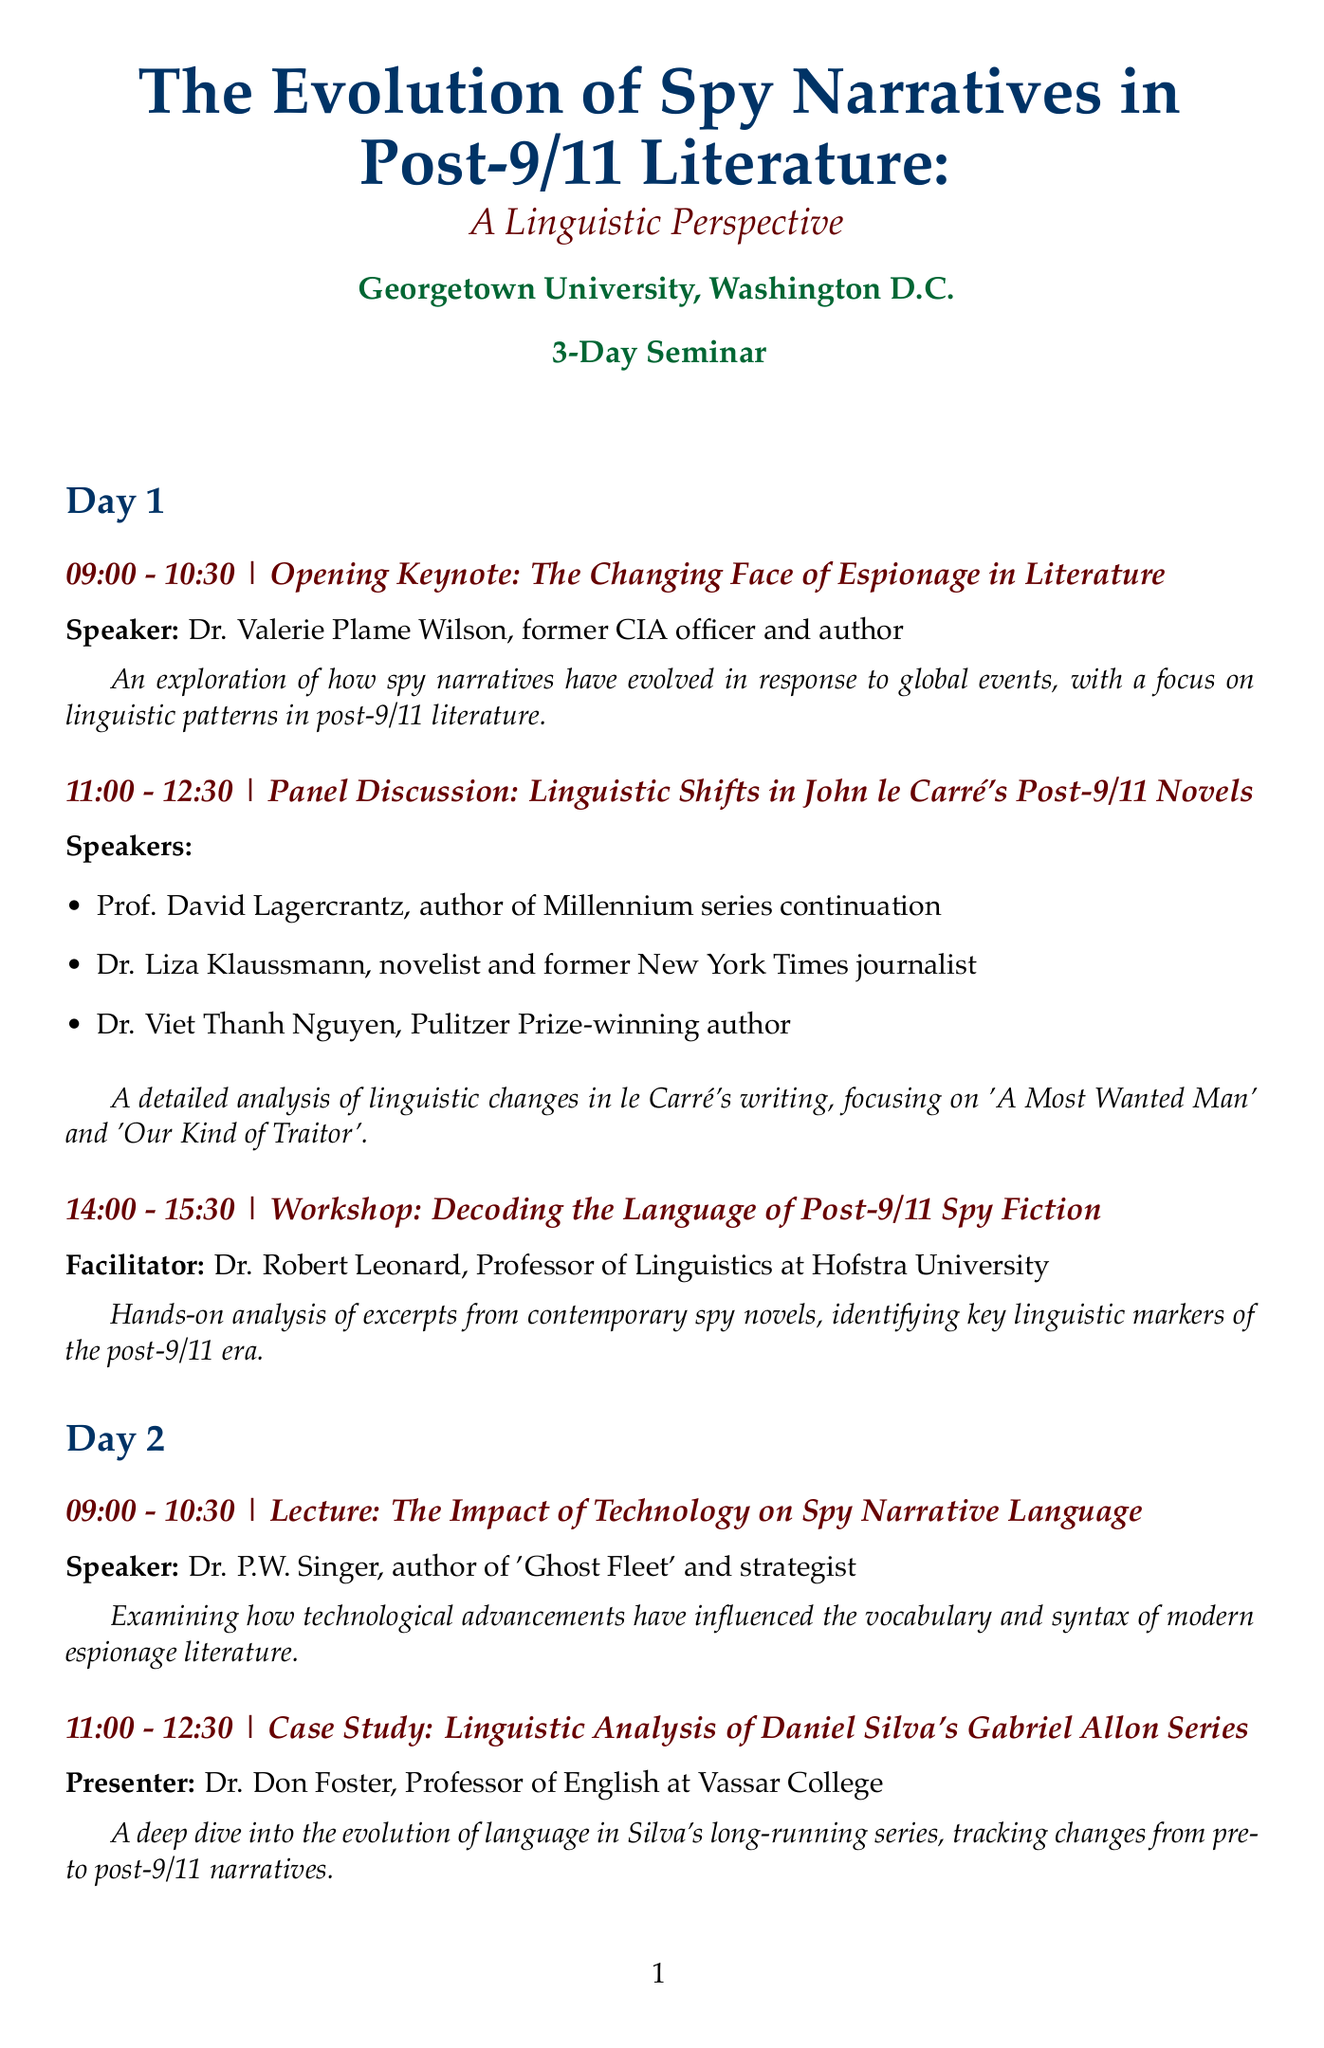What is the title of the seminar? The title is clearly stated at the start of the document.
Answer: The Evolution of Spy Narratives in Post-9/11 Literature: A Linguistic Perspective Who is the speaker of the opening keynote? The speaker for the opening keynote is listed directly beneath the session title.
Answer: Dr. Valerie Plame Wilson What time does the panel discussion on John le Carré's novels take place? The time is specified next to the title of the panel discussion.
Answer: 11:00 - 12:30 Which university is hosting the seminar? The hosting university is mentioned in the location section at the top of the document.
Answer: Georgetown University How many days does the seminar span? The total duration of the seminar is indicated at the beginning of the document.
Answer: 3 days What is the focus of Dr. P.W. Singer's lecture? The focus of the lecture is outlined in the description beneath the session title.
Answer: The Impact of Technology on Spy Narrative Language Who facilitates the workshop on decoding language? The facilitator's name is listed right after the workshop title.
Answer: Dr. Robert Leonard What type of session occurs at 14:00 on Day 2? The session type is specified in the title for that particular slot.
Answer: Interactive Session What is a key theme explored in the closing address? The theme is described in the last session's description, highlighting the central focus of the address.
Answer: The Enduring Appeal of Spy Language in Literature 